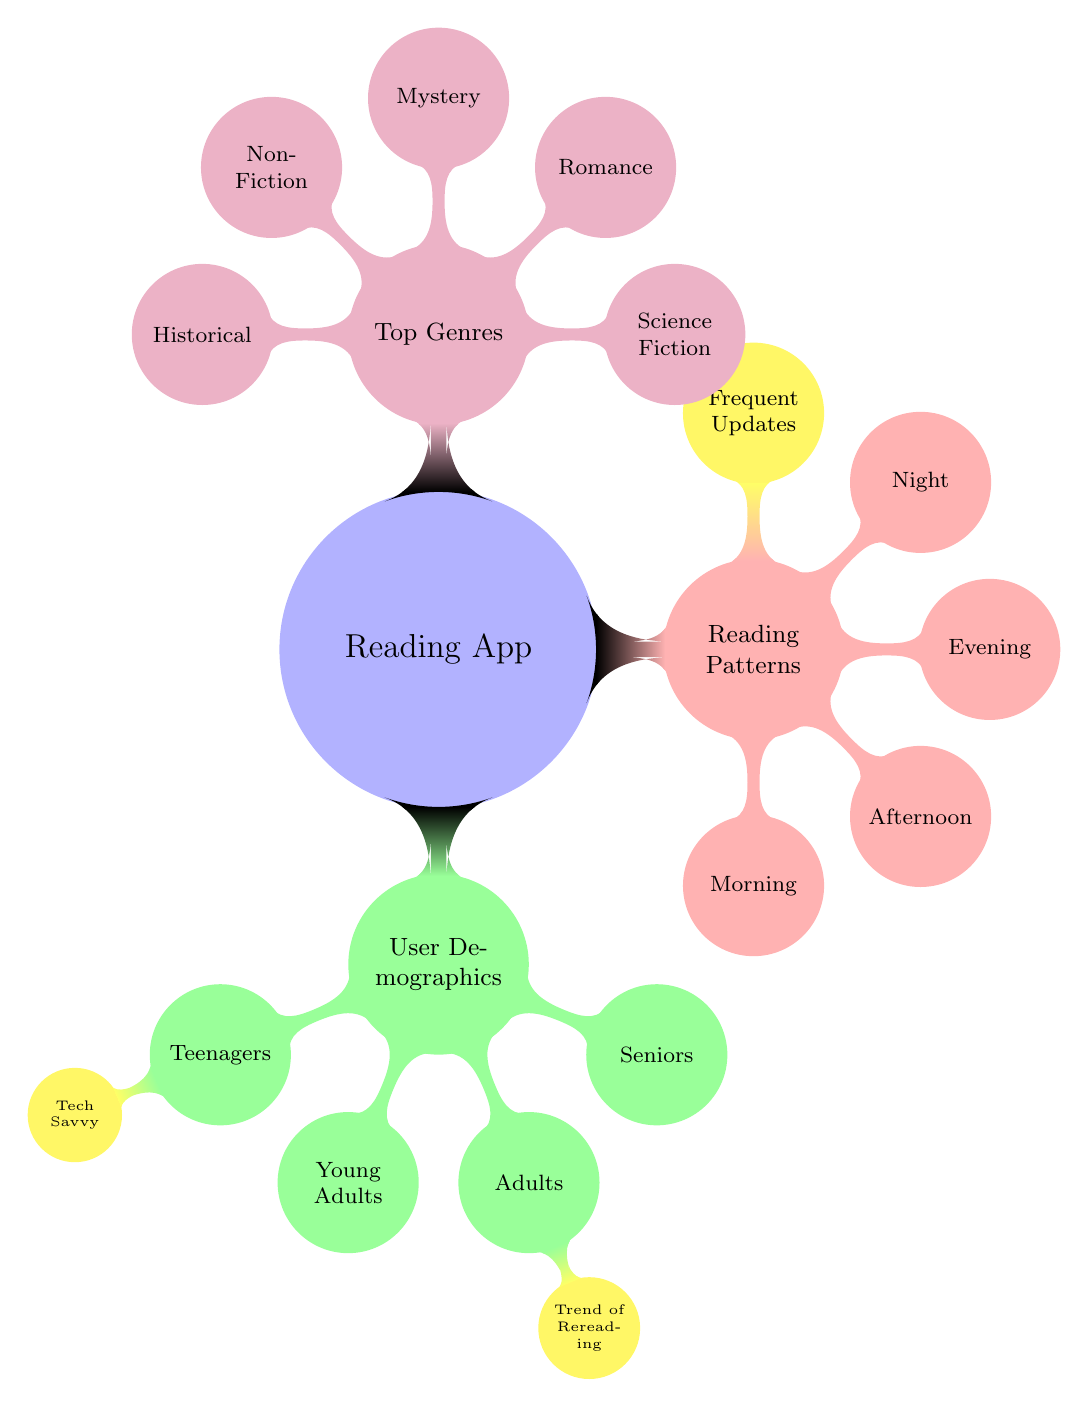What are the user demographics identified in the diagram? The diagram displays four user demographics categorized under the main topic "User Demographics": Teenagers, Young Adults, Adults, and Seniors.
Answer: Teenagers, Young Adults, Adults, Seniors Which demographic has a noted trend of rereading? In the diagram, the "Adults" category has a child node that explicitly mentions "Trend of Rereading," indicating that this demographic frequently re-reads books.
Answer: Adults How many main branches are there in the Reading App diagram? The main topic "Reading App" has three primary branches: User Demographics, Reading Patterns, and Top Genres, making a total of three branches.
Answer: 3 What time of day is not mentioned in the Reading Patterns section? The diagram outlines Reading Patterns divided into Morning, Afternoon, Evening, and Night; since all these times are covered, no times are omitted.
Answer: None Which reading pattern node indicates user engagement during late hours? The "Night" node under the Reading Patterns specifically refers to reading during late hours, suggesting when users are most engaged at night.
Answer: Night What genre is located at the top of the Top Genres branch? The first genre listed in the Top Genres segment of the diagram is "Science Fiction," indicating it is likely the most popular among users.
Answer: Science Fiction How is the demographic of Seniors illustrated without any sub-nodes? In the diagram, "Seniors" is represented as a standalone node under User Demographics, showing it does not have any additional branching details or characteristics elaborated.
Answer: Standalone node How are frequent updates represented in relation to Reading Patterns? The "Frequent Updates" node is part of the Reading Patterns branch, indicating it is an essential element of user reading behavior alongside designated times of the day.
Answer: Part of Reading Patterns What color represents the Reading Patterns branch in the diagram? The Reading Patterns branch is illustrated in red, differentiating it from other branches such as User Demographics and Top Genres.
Answer: Red 